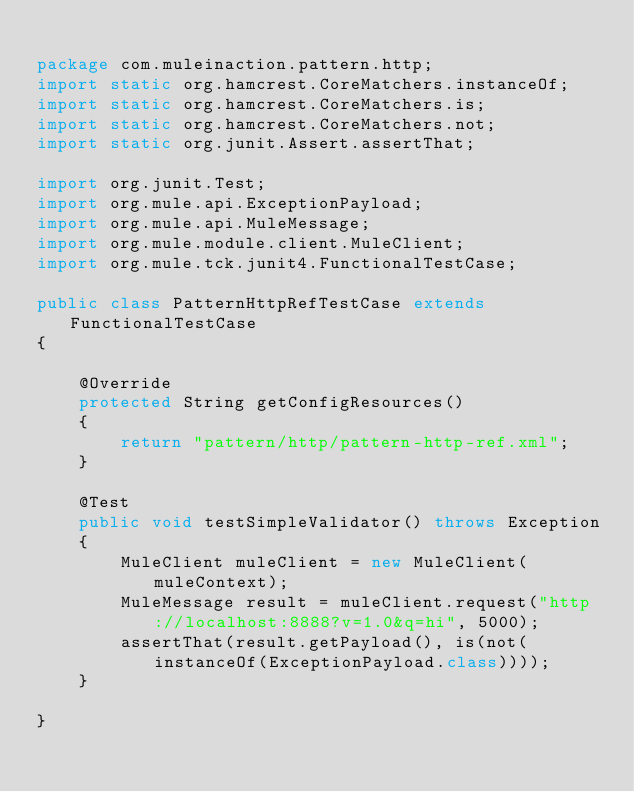<code> <loc_0><loc_0><loc_500><loc_500><_Java_>
package com.muleinaction.pattern.http;
import static org.hamcrest.CoreMatchers.instanceOf;
import static org.hamcrest.CoreMatchers.is;
import static org.hamcrest.CoreMatchers.not;
import static org.junit.Assert.assertThat;

import org.junit.Test;
import org.mule.api.ExceptionPayload;
import org.mule.api.MuleMessage;
import org.mule.module.client.MuleClient;
import org.mule.tck.junit4.FunctionalTestCase;

public class PatternHttpRefTestCase extends FunctionalTestCase
{

    @Override
    protected String getConfigResources()
    {
        return "pattern/http/pattern-http-ref.xml";
    }

    @Test
    public void testSimpleValidator() throws Exception
    {
        MuleClient muleClient = new MuleClient(muleContext);
        MuleMessage result = muleClient.request("http://localhost:8888?v=1.0&q=hi", 5000);
        assertThat(result.getPayload(), is(not(instanceOf(ExceptionPayload.class))));
    }
    
}
</code> 